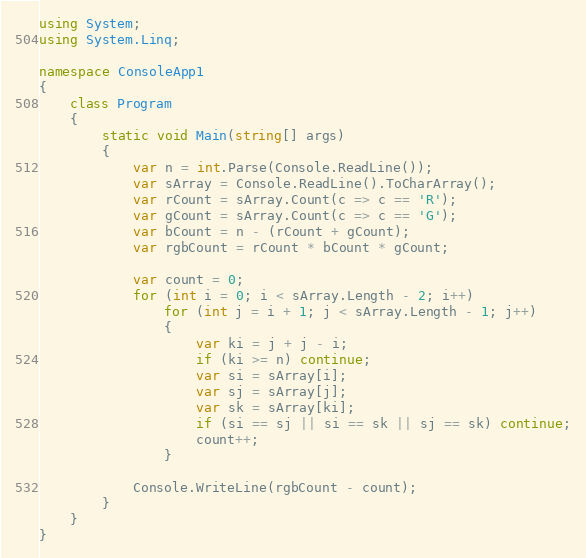Convert code to text. <code><loc_0><loc_0><loc_500><loc_500><_C#_>using System;
using System.Linq;

namespace ConsoleApp1
{
    class Program
    {
        static void Main(string[] args)
        {
            var n = int.Parse(Console.ReadLine());
            var sArray = Console.ReadLine().ToCharArray();
            var rCount = sArray.Count(c => c == 'R');
            var gCount = sArray.Count(c => c == 'G');
            var bCount = n - (rCount + gCount);
            var rgbCount = rCount * bCount * gCount;

            var count = 0;
            for (int i = 0; i < sArray.Length - 2; i++)
                for (int j = i + 1; j < sArray.Length - 1; j++)
                {
                    var ki = j + j - i;
                    if (ki >= n) continue;
                    var si = sArray[i];
                    var sj = sArray[j];
                    var sk = sArray[ki];
                    if (si == sj || si == sk || sj == sk) continue;
                    count++;
                }

            Console.WriteLine(rgbCount - count);
        }
    }
}
</code> 